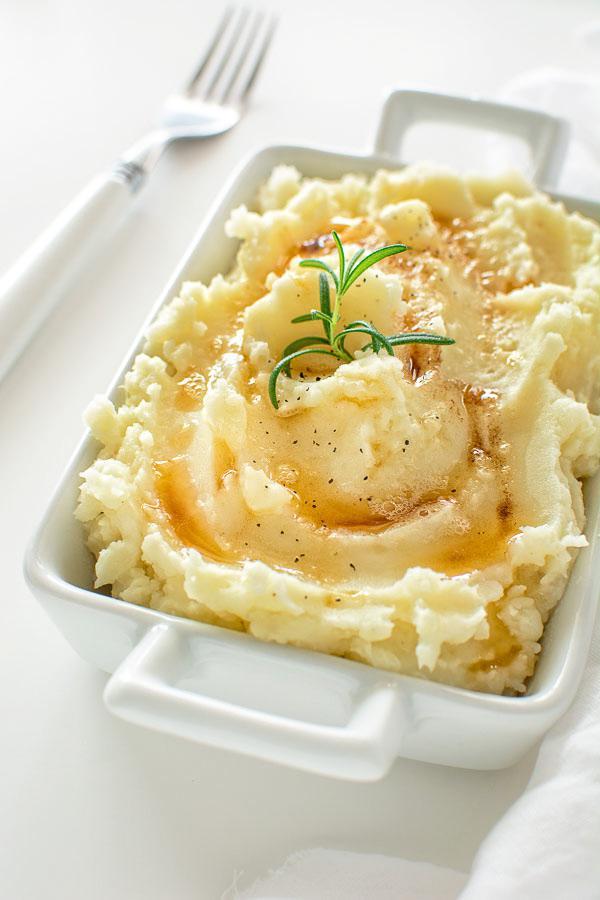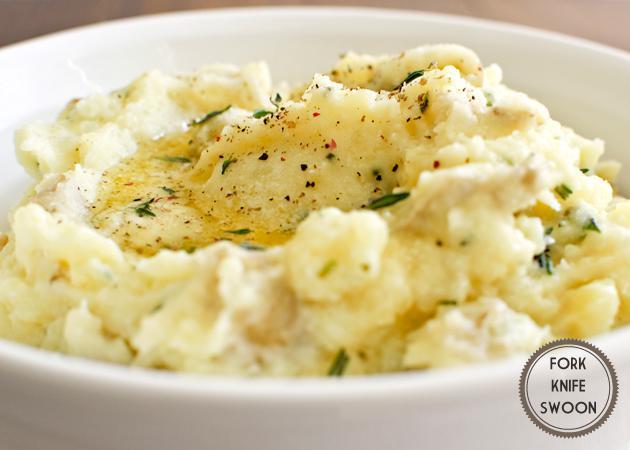The first image is the image on the left, the second image is the image on the right. For the images shown, is this caption "One bowl of potatoes has only green chive garnish." true? Answer yes or no. No. The first image is the image on the left, the second image is the image on the right. Examine the images to the left and right. Is the description "there is a utensil in one of the images" accurate? Answer yes or no. Yes. 